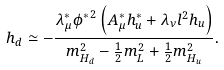Convert formula to latex. <formula><loc_0><loc_0><loc_500><loc_500>h _ { d } \simeq - \frac { \lambda _ { \mu } ^ { * } { \phi ^ { * } } ^ { 2 } \left ( A _ { \mu } ^ { * } h _ { u } ^ { * } + \lambda _ { \nu } l ^ { 2 } h _ { u } \right ) } { m _ { H _ { d } } ^ { 2 } - \frac { 1 } { 2 } m _ { L } ^ { 2 } + \frac { 1 } { 2 } m _ { H _ { u } } ^ { 2 } } .</formula> 